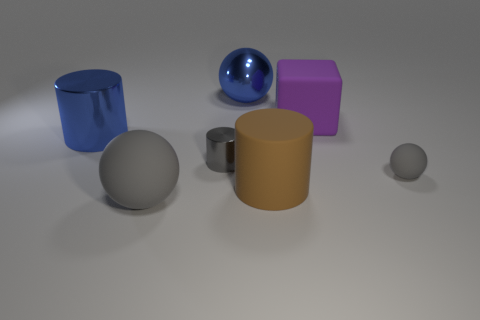Add 1 big brown rubber cylinders. How many objects exist? 8 Subtract all blocks. How many objects are left? 6 Subtract all cyan metallic things. Subtract all matte balls. How many objects are left? 5 Add 3 blue objects. How many blue objects are left? 5 Add 7 blue shiny spheres. How many blue shiny spheres exist? 8 Subtract 0 red cylinders. How many objects are left? 7 